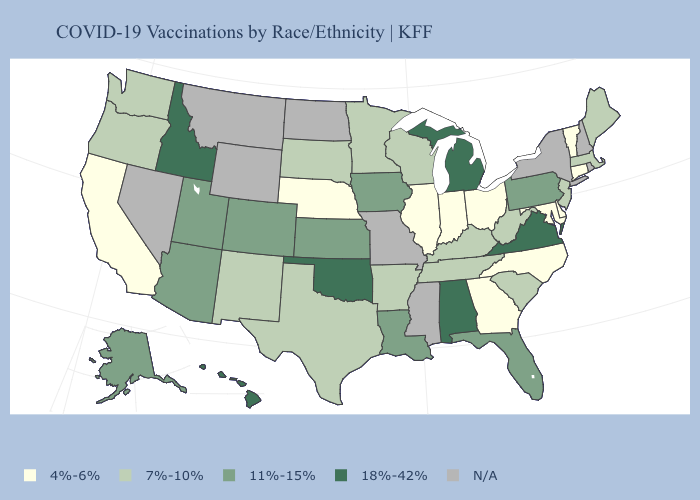Name the states that have a value in the range 4%-6%?
Quick response, please. California, Connecticut, Delaware, Georgia, Illinois, Indiana, Maryland, Nebraska, North Carolina, Ohio, Vermont. Among the states that border Tennessee , does Georgia have the highest value?
Short answer required. No. Which states have the highest value in the USA?
Answer briefly. Alabama, Hawaii, Idaho, Michigan, Oklahoma, Virginia. Is the legend a continuous bar?
Concise answer only. No. Name the states that have a value in the range 4%-6%?
Quick response, please. California, Connecticut, Delaware, Georgia, Illinois, Indiana, Maryland, Nebraska, North Carolina, Ohio, Vermont. Among the states that border Delaware , does Maryland have the highest value?
Be succinct. No. What is the value of Montana?
Be succinct. N/A. Name the states that have a value in the range 18%-42%?
Quick response, please. Alabama, Hawaii, Idaho, Michigan, Oklahoma, Virginia. How many symbols are there in the legend?
Short answer required. 5. What is the value of Oregon?
Be succinct. 7%-10%. Name the states that have a value in the range 7%-10%?
Answer briefly. Arkansas, Kentucky, Maine, Massachusetts, Minnesota, New Jersey, New Mexico, Oregon, South Carolina, South Dakota, Tennessee, Texas, Washington, West Virginia, Wisconsin. What is the highest value in the USA?
Be succinct. 18%-42%. What is the value of Arizona?
Short answer required. 11%-15%. 